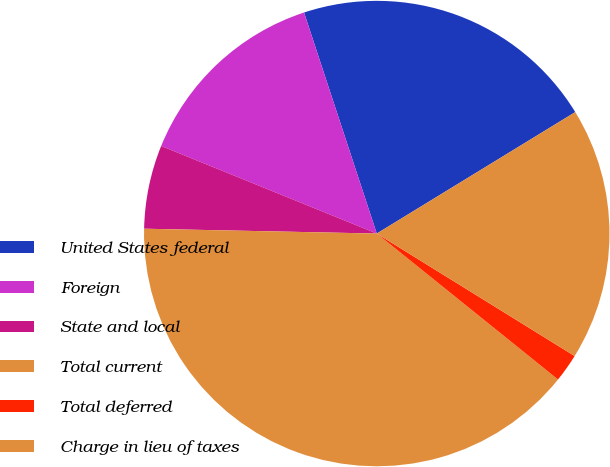Convert chart to OTSL. <chart><loc_0><loc_0><loc_500><loc_500><pie_chart><fcel>United States federal<fcel>Foreign<fcel>State and local<fcel>Total current<fcel>Total deferred<fcel>Charge in lieu of taxes<nl><fcel>21.32%<fcel>13.8%<fcel>5.81%<fcel>39.54%<fcel>1.97%<fcel>17.56%<nl></chart> 